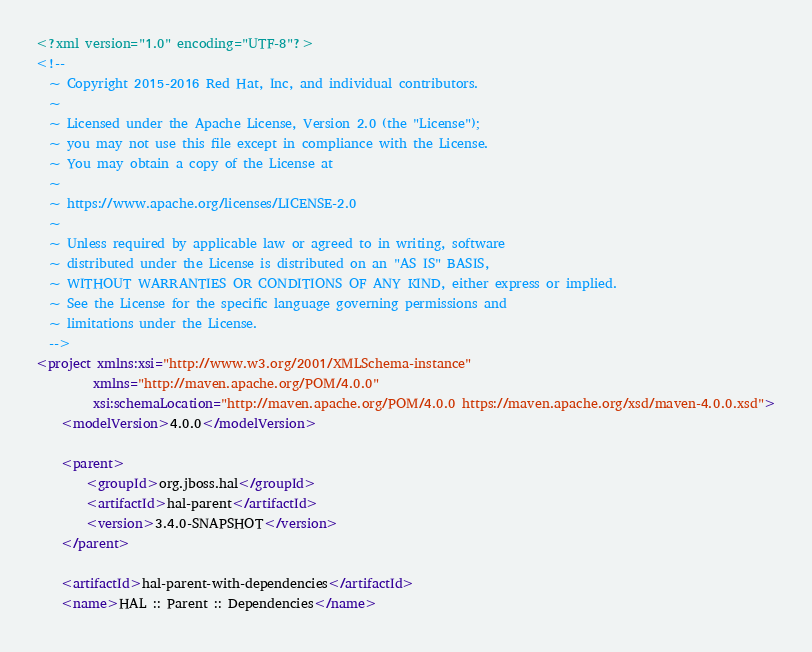Convert code to text. <code><loc_0><loc_0><loc_500><loc_500><_XML_><?xml version="1.0" encoding="UTF-8"?>
<!--
  ~ Copyright 2015-2016 Red Hat, Inc, and individual contributors.
  ~
  ~ Licensed under the Apache License, Version 2.0 (the "License");
  ~ you may not use this file except in compliance with the License.
  ~ You may obtain a copy of the License at
  ~
  ~ https://www.apache.org/licenses/LICENSE-2.0
  ~
  ~ Unless required by applicable law or agreed to in writing, software
  ~ distributed under the License is distributed on an "AS IS" BASIS,
  ~ WITHOUT WARRANTIES OR CONDITIONS OF ANY KIND, either express or implied.
  ~ See the License for the specific language governing permissions and
  ~ limitations under the License.
  -->
<project xmlns:xsi="http://www.w3.org/2001/XMLSchema-instance"
         xmlns="http://maven.apache.org/POM/4.0.0"
         xsi:schemaLocation="http://maven.apache.org/POM/4.0.0 https://maven.apache.org/xsd/maven-4.0.0.xsd">
    <modelVersion>4.0.0</modelVersion>

    <parent>
        <groupId>org.jboss.hal</groupId>
        <artifactId>hal-parent</artifactId>
        <version>3.4.0-SNAPSHOT</version>
    </parent>

    <artifactId>hal-parent-with-dependencies</artifactId>
    <name>HAL :: Parent :: Dependencies</name></code> 